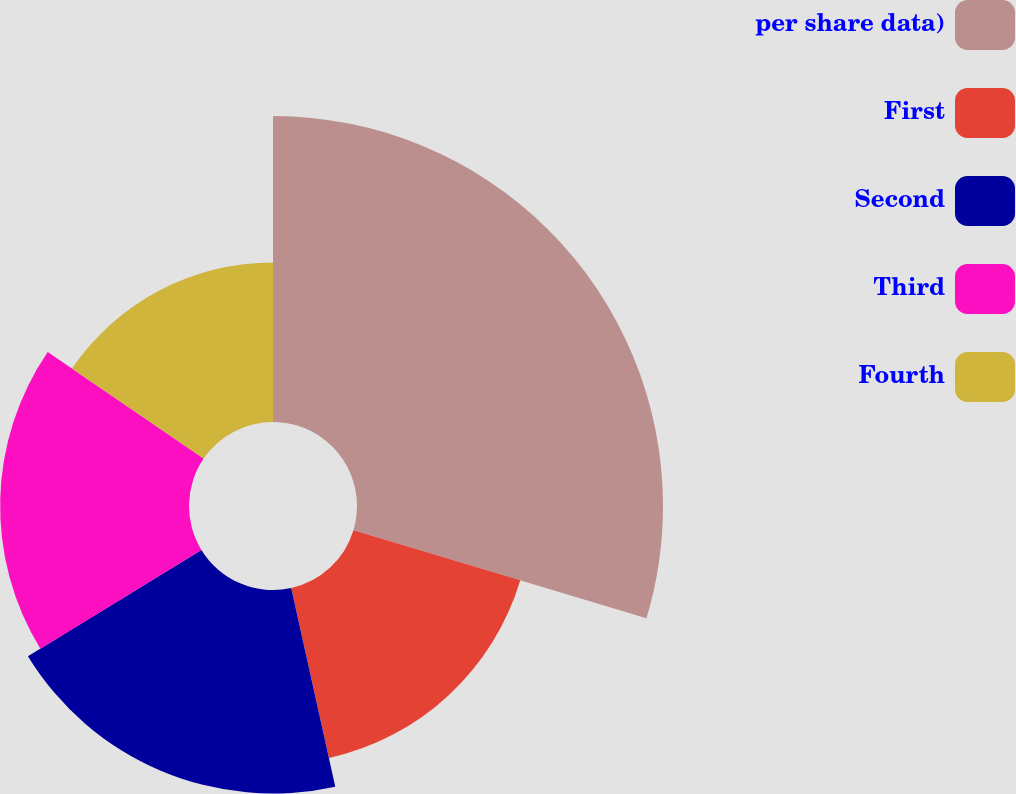Convert chart to OTSL. <chart><loc_0><loc_0><loc_500><loc_500><pie_chart><fcel>per share data)<fcel>First<fcel>Second<fcel>Third<fcel>Fourth<nl><fcel>29.65%<fcel>16.88%<fcel>19.72%<fcel>18.3%<fcel>15.46%<nl></chart> 